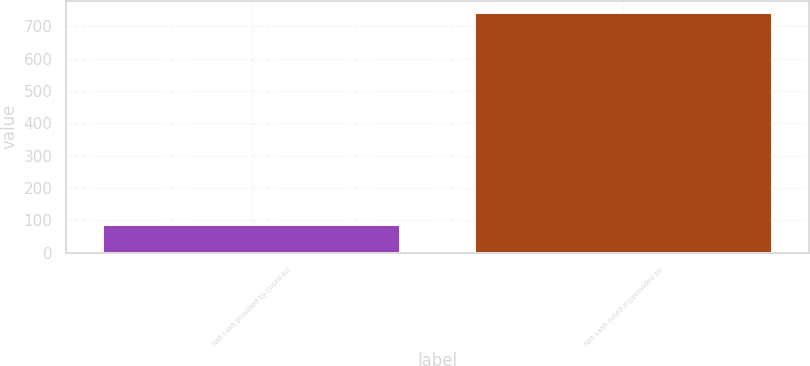Convert chart. <chart><loc_0><loc_0><loc_500><loc_500><bar_chart><fcel>Net cash provided by/(used in)<fcel>Net cash (used in)/provided by<nl><fcel>84.4<fcel>742.4<nl></chart> 